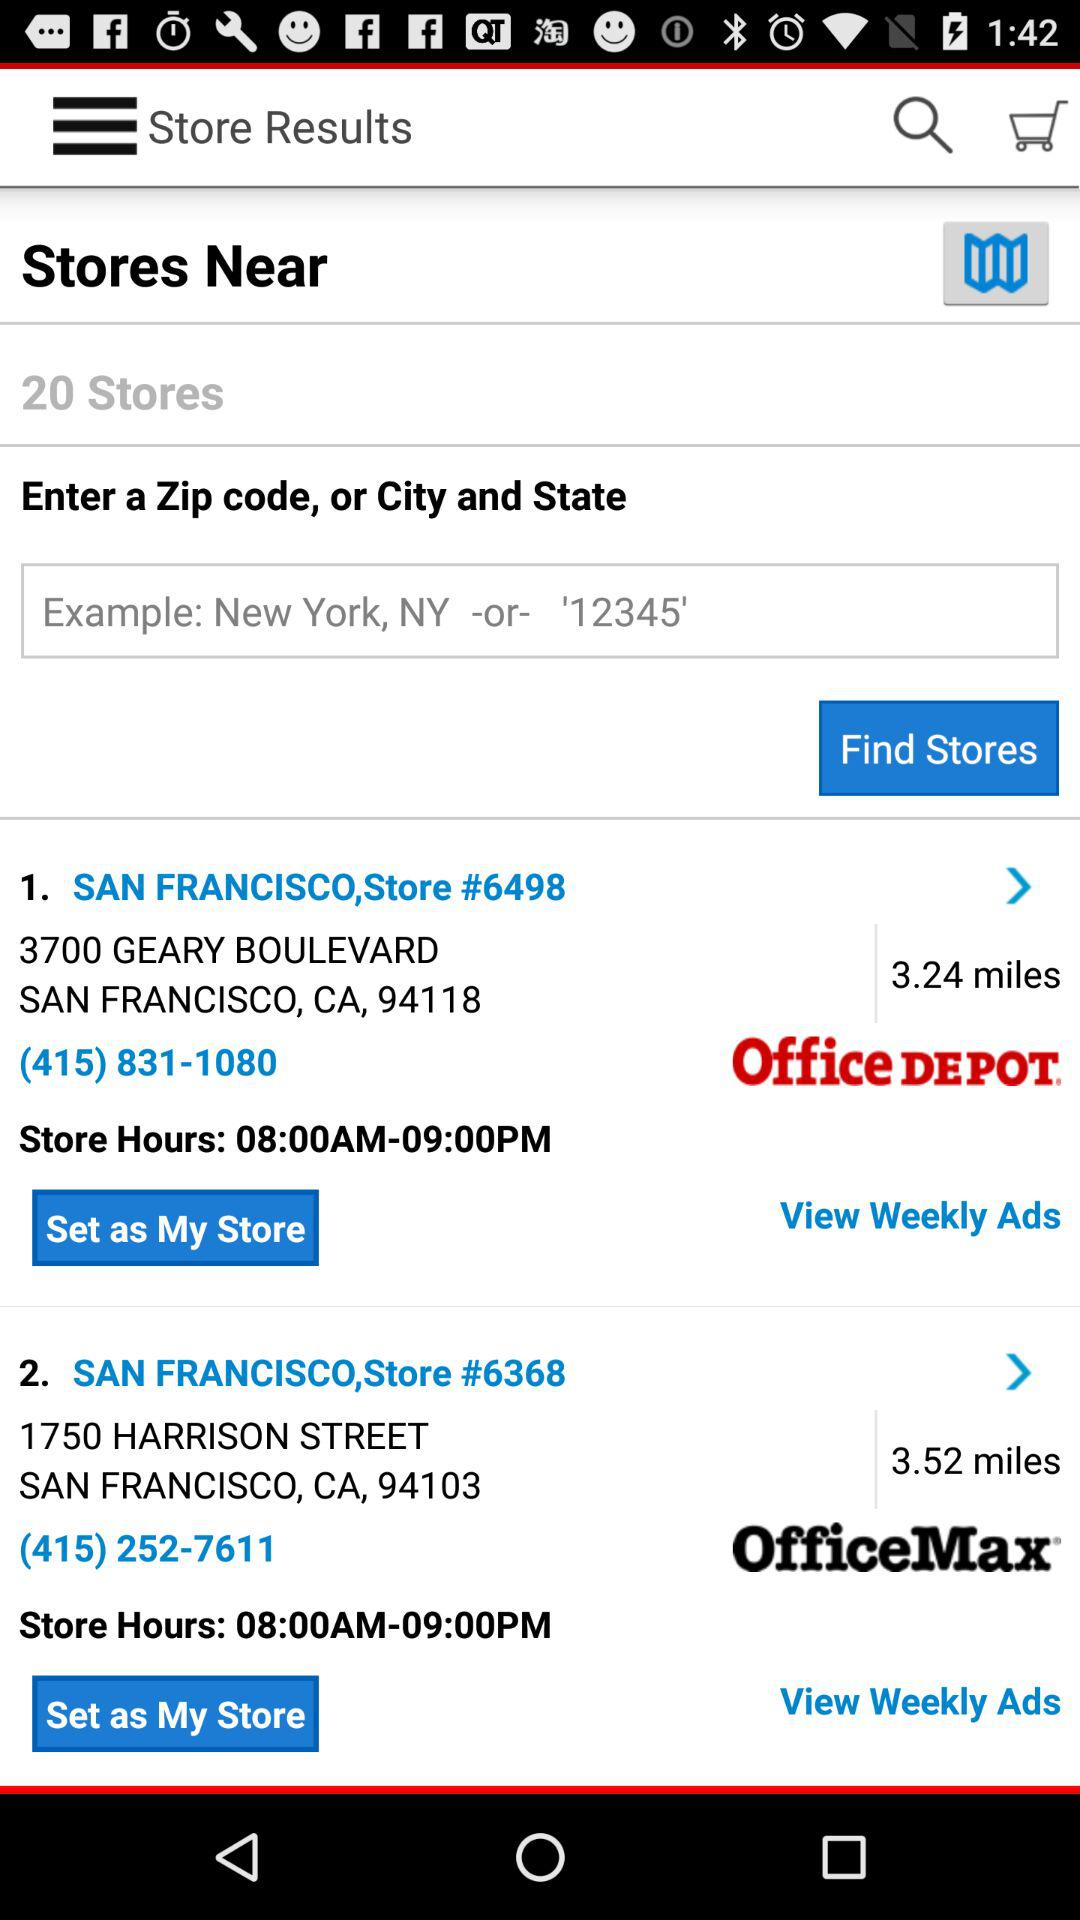What are the hours of San Francisco, Store #6368? The hours of San Francisco, Store #6368 are 8:00 a.m. to 9:00 p.m. 